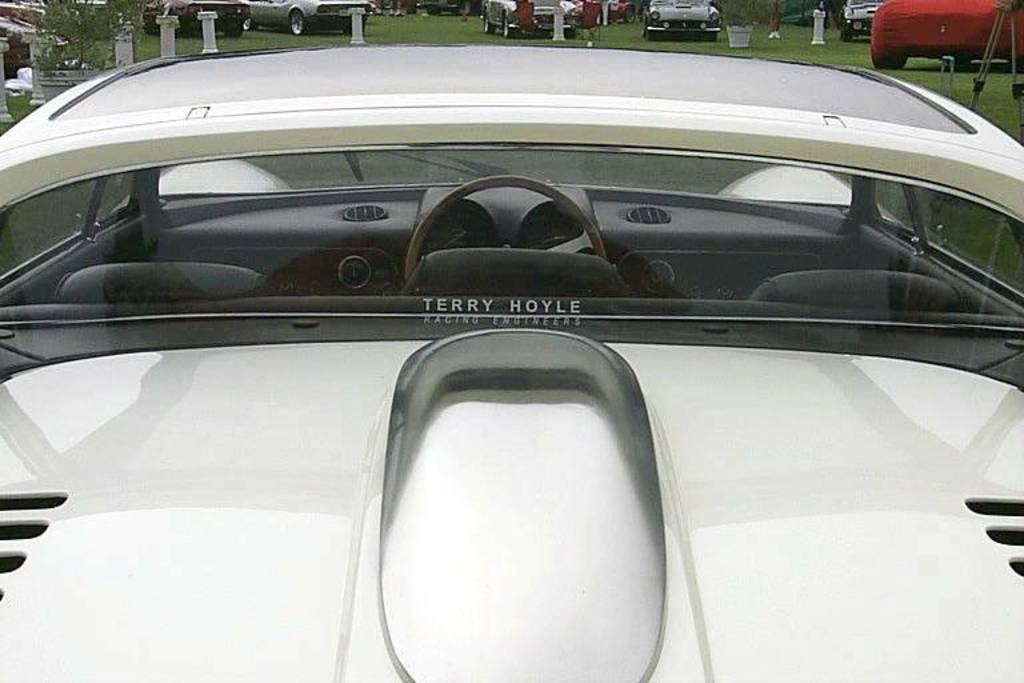Can you describe this image briefly? In this image there is a white car truncated, there is a plant, there is grass, there are cars. 